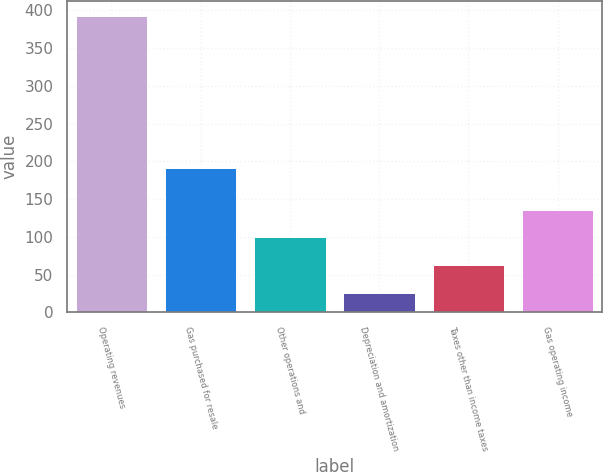Convert chart to OTSL. <chart><loc_0><loc_0><loc_500><loc_500><bar_chart><fcel>Operating revenues<fcel>Gas purchased for resale<fcel>Other operations and<fcel>Depreciation and amortization<fcel>Taxes other than income taxes<fcel>Gas operating income<nl><fcel>393<fcel>191<fcel>99.4<fcel>26<fcel>62.7<fcel>136.1<nl></chart> 